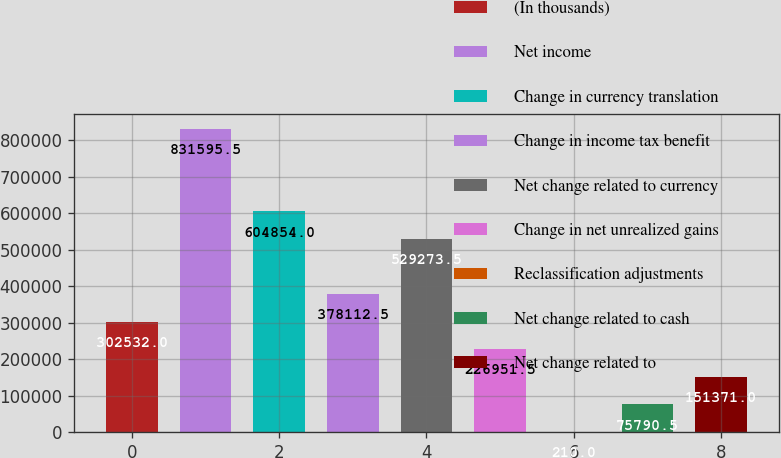Convert chart to OTSL. <chart><loc_0><loc_0><loc_500><loc_500><bar_chart><fcel>(In thousands)<fcel>Net income<fcel>Change in currency translation<fcel>Change in income tax benefit<fcel>Net change related to currency<fcel>Change in net unrealized gains<fcel>Reclassification adjustments<fcel>Net change related to cash<fcel>Net change related to<nl><fcel>302532<fcel>831596<fcel>604854<fcel>378112<fcel>529274<fcel>226952<fcel>210<fcel>75790.5<fcel>151371<nl></chart> 